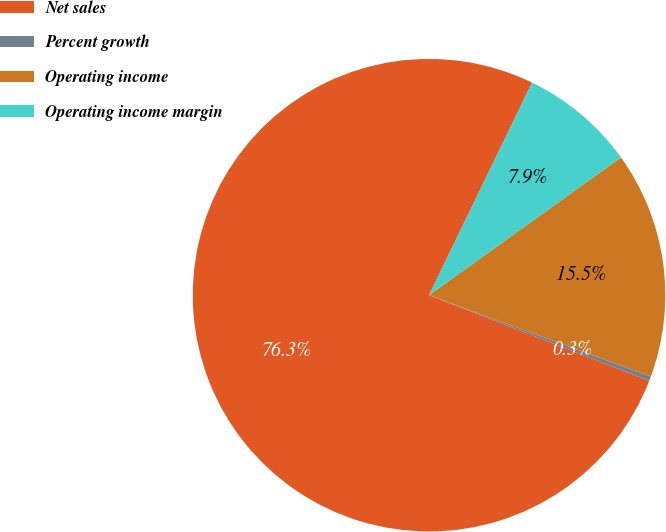Convert chart. <chart><loc_0><loc_0><loc_500><loc_500><pie_chart><fcel>Net sales<fcel>Percent growth<fcel>Operating income<fcel>Operating income margin<nl><fcel>76.28%<fcel>0.31%<fcel>15.5%<fcel>7.91%<nl></chart> 